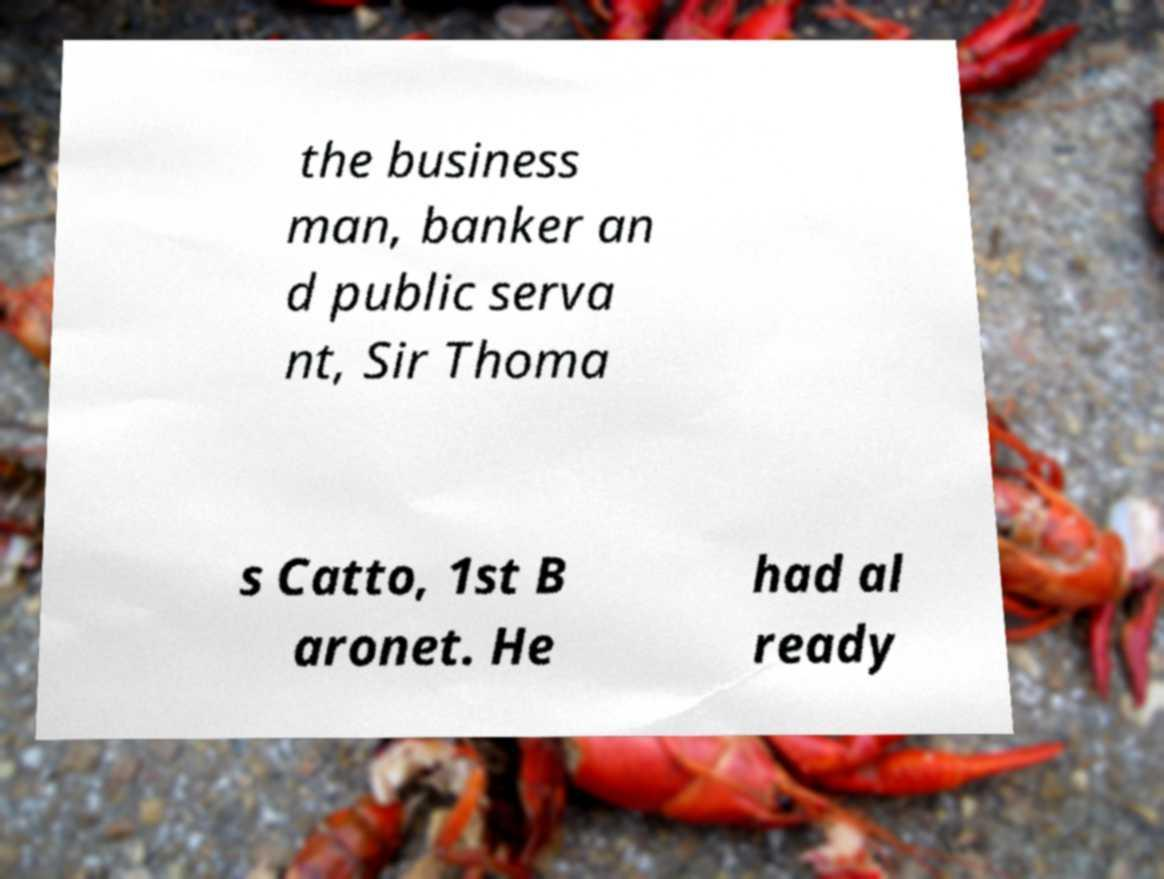Can you read and provide the text displayed in the image?This photo seems to have some interesting text. Can you extract and type it out for me? the business man, banker an d public serva nt, Sir Thoma s Catto, 1st B aronet. He had al ready 